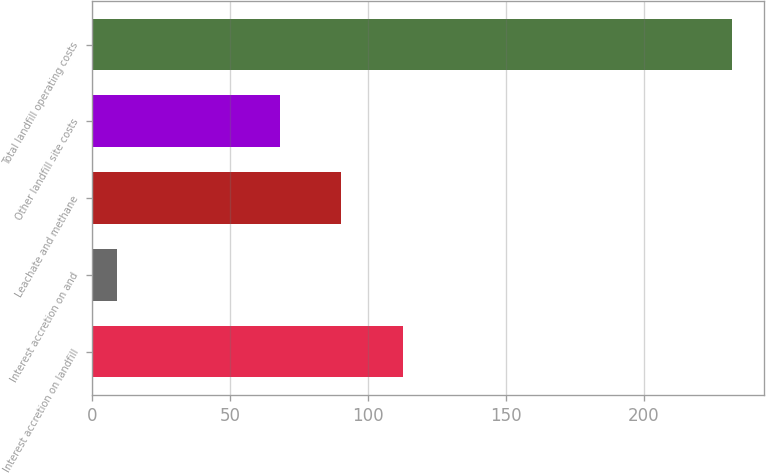Convert chart. <chart><loc_0><loc_0><loc_500><loc_500><bar_chart><fcel>Interest accretion on landfill<fcel>Interest accretion on and<fcel>Leachate and methane<fcel>Other landfill site costs<fcel>Total landfill operating costs<nl><fcel>112.6<fcel>9<fcel>90.3<fcel>68<fcel>232<nl></chart> 